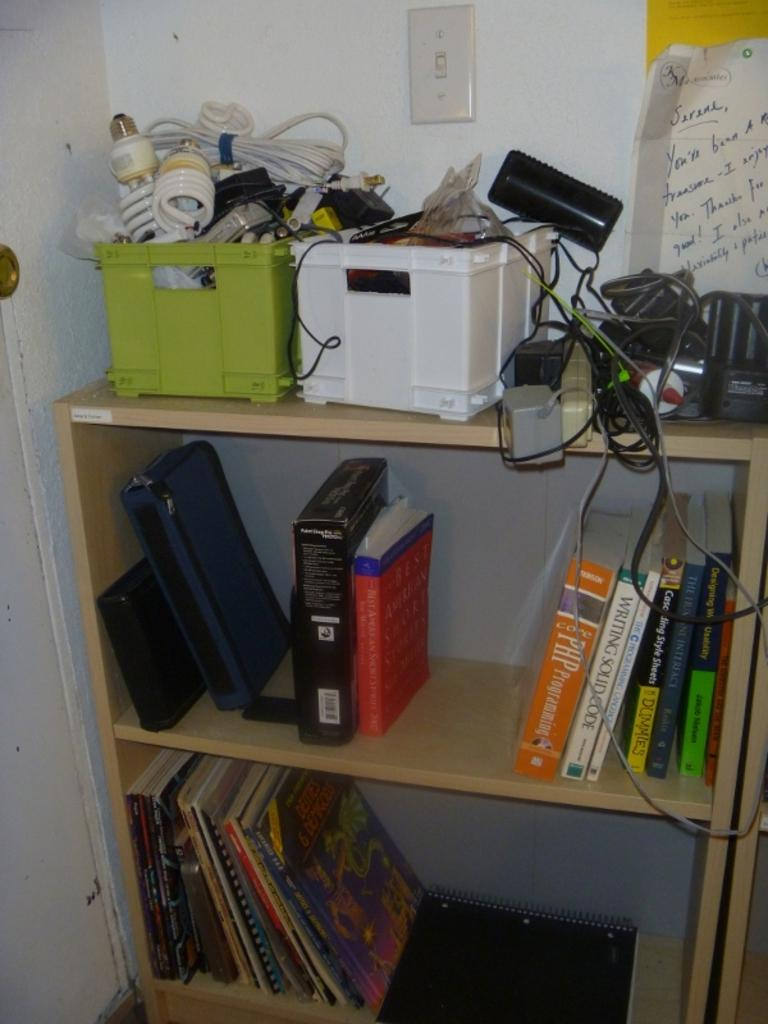What type of furniture is visible in the image? There are bookshelves in the image. What is placed on top of the bookshelves? There are boxes on top of the bookshelves. Are there any additional items associated with the boxes? Wires are present along with the boxes. What can be seen attached to the wall in the image? There is a paper attached to the wall. What type of calculator is present on the bookshelf in the image? There is no calculator present on the bookshelf in the image. 